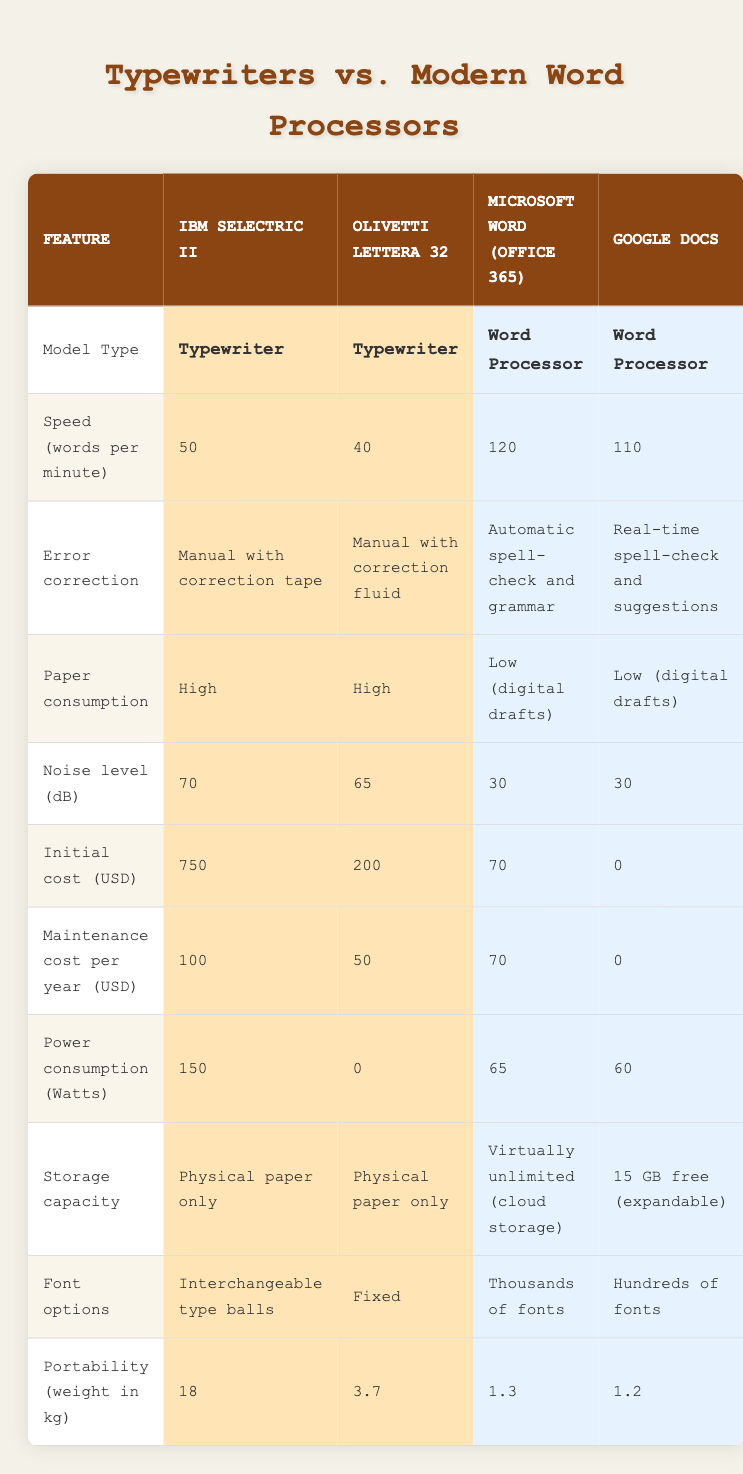What is the speed (in words per minute) of the IBM Selectric II? The table shows that the speed of the IBM Selectric II is specifically listed under the "Speed (words per minute)" row. The value provided is 50 words per minute.
Answer: 50 Which model has the lowest noise level? By comparing the "Noise level (dB)" values for all models, the IBM Selectric II has a noise level of 70 dB, the Olivetti Lettera 32 has 65 dB, and both the Microsoft Word and Google Docs have 30 dB. Thus, Microsoft Word and Google Docs have the lowest noise level of 30 dB.
Answer: Microsoft Word and Google Docs What is the initial cost of the Olivetti Lettera 32? In the "Initial cost (USD)" row, the Olivetti Lettera 32 is listed with a cost of 200 USD.
Answer: 200 Is the maintenance cost per year for Google Docs more than for the IBM Selectric II? The maintenance cost for Google Docs is listed as 0 USD, while for the IBM Selectric II, it is 100 USD. Since 0 is not more than 100, the answer is no.
Answer: No What is the difference in power consumption between the IBM Selectric II and Google Docs? The IBM Selectric II consumes 150 Watts, and Google Docs consumes 60 Watts. To find the difference, we subtract the power consumption of Google Docs from that of the IBM Selectric II: 150 - 60 = 90 Watts.
Answer: 90 If we consider speed as a primary factor, which model performs better on average among typewriters vs. modern word processors? The average speed of typewriters: (50 + 40) / 2 = 45 words per minute, and the average speed of modern word processors: (120 + 110) / 2 = 115 words per minute. Since 115 > 45, modern word processors perform better on average regarding speed.
Answer: Modern word processors How many more font options does Microsoft Word have compared to the Olivetti Lettera 32? Microsoft Word offers thousands of fonts, while the Olivetti Lettera 32 has fixed font options. The exact numerical difference isn't quantifiable for "thousands," but we can conclude that Microsoft Word has significantly more font options than the fixed options of the Olivetti Lettera 32.
Answer: Significantly more Which model has the highest paper consumption? The table indicates that both the IBM Selectric II and the Olivetti Lettera 32 have "High" paper consumption, while the modern word processors have "Low (digital drafts)." Thus, both typewriters have the highest paper consumption.
Answer: Both typewriters What is the total weight of the IBM Selectric II and the Olivetti Lettera 32 combined? The weight of the IBM Selectric II is 18 kg, and the Olivetti Lettera 32 weighs 3.7 kg. The total weight is found by adding these two values together: 18 + 3.7 = 21.7 kg.
Answer: 21.7 kg 